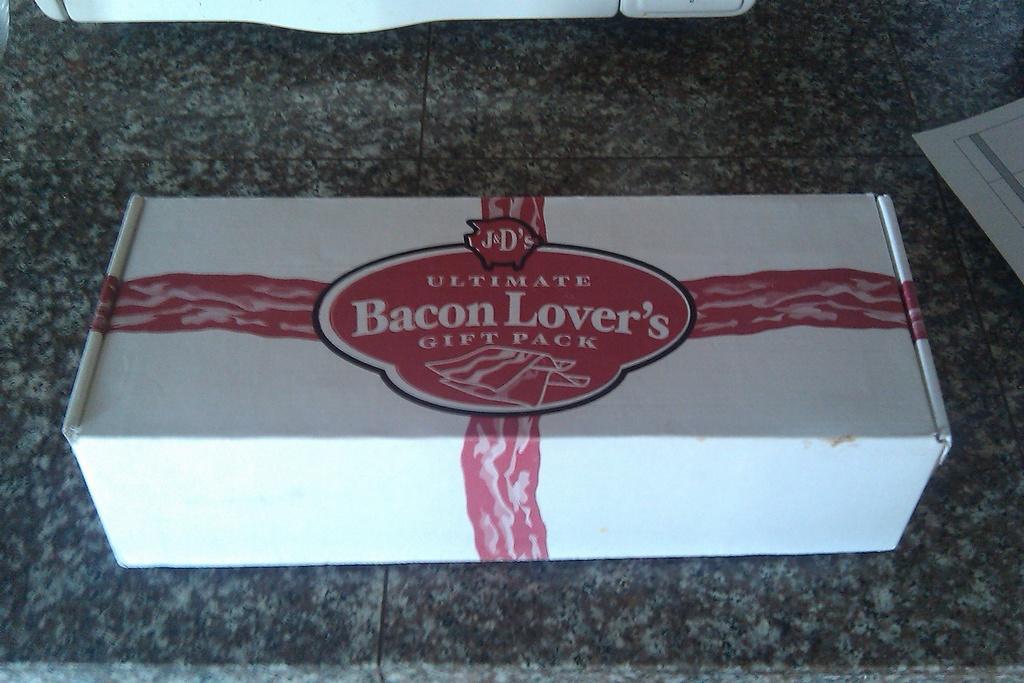How would you summarize this image in a sentence or two? In the center of the image there is a box placed on countertop. 